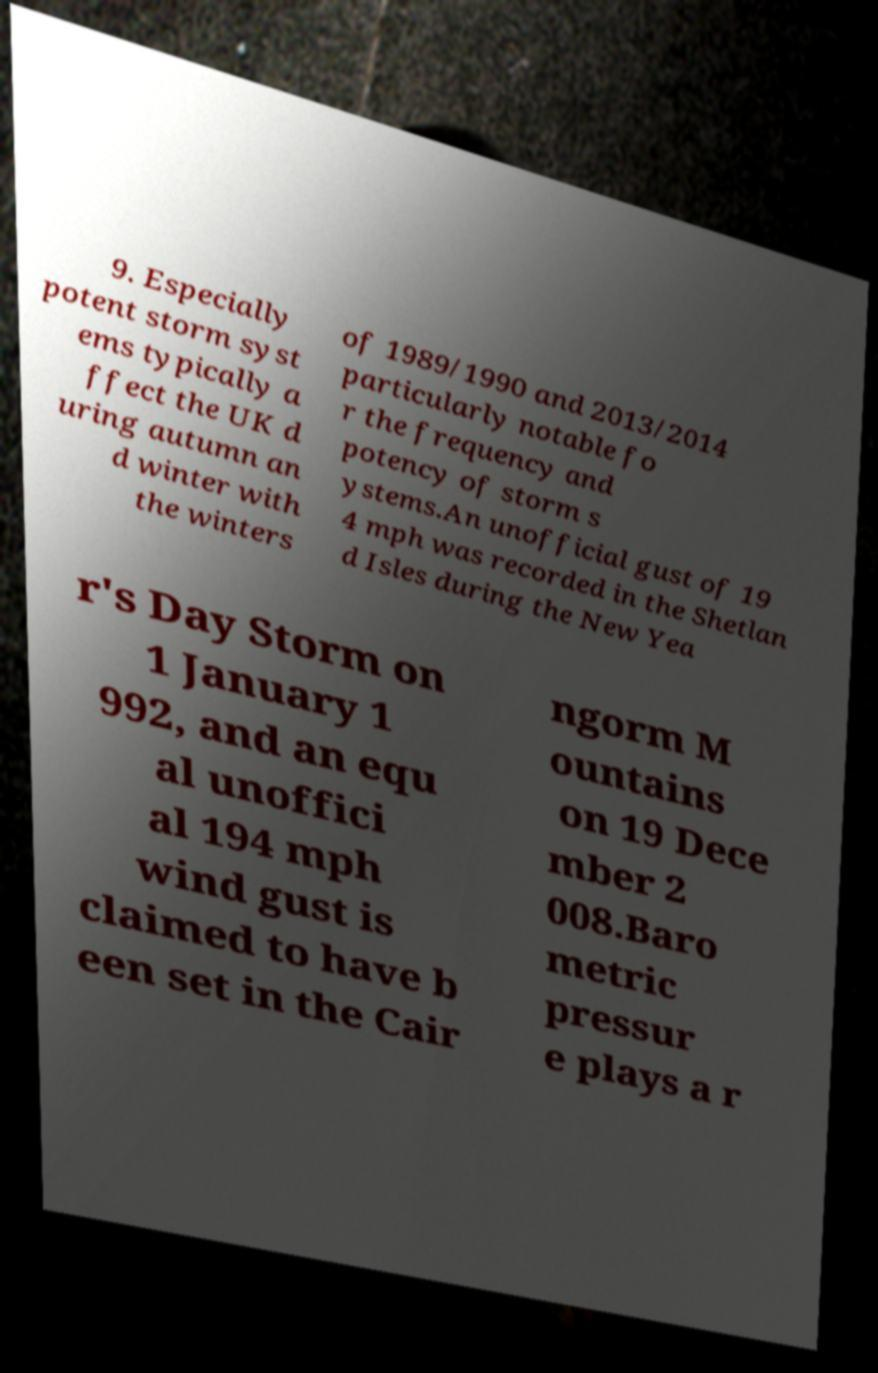For documentation purposes, I need the text within this image transcribed. Could you provide that? 9. Especially potent storm syst ems typically a ffect the UK d uring autumn an d winter with the winters of 1989/1990 and 2013/2014 particularly notable fo r the frequency and potency of storm s ystems.An unofficial gust of 19 4 mph was recorded in the Shetlan d Isles during the New Yea r's Day Storm on 1 January 1 992, and an equ al unoffici al 194 mph wind gust is claimed to have b een set in the Cair ngorm M ountains on 19 Dece mber 2 008.Baro metric pressur e plays a r 